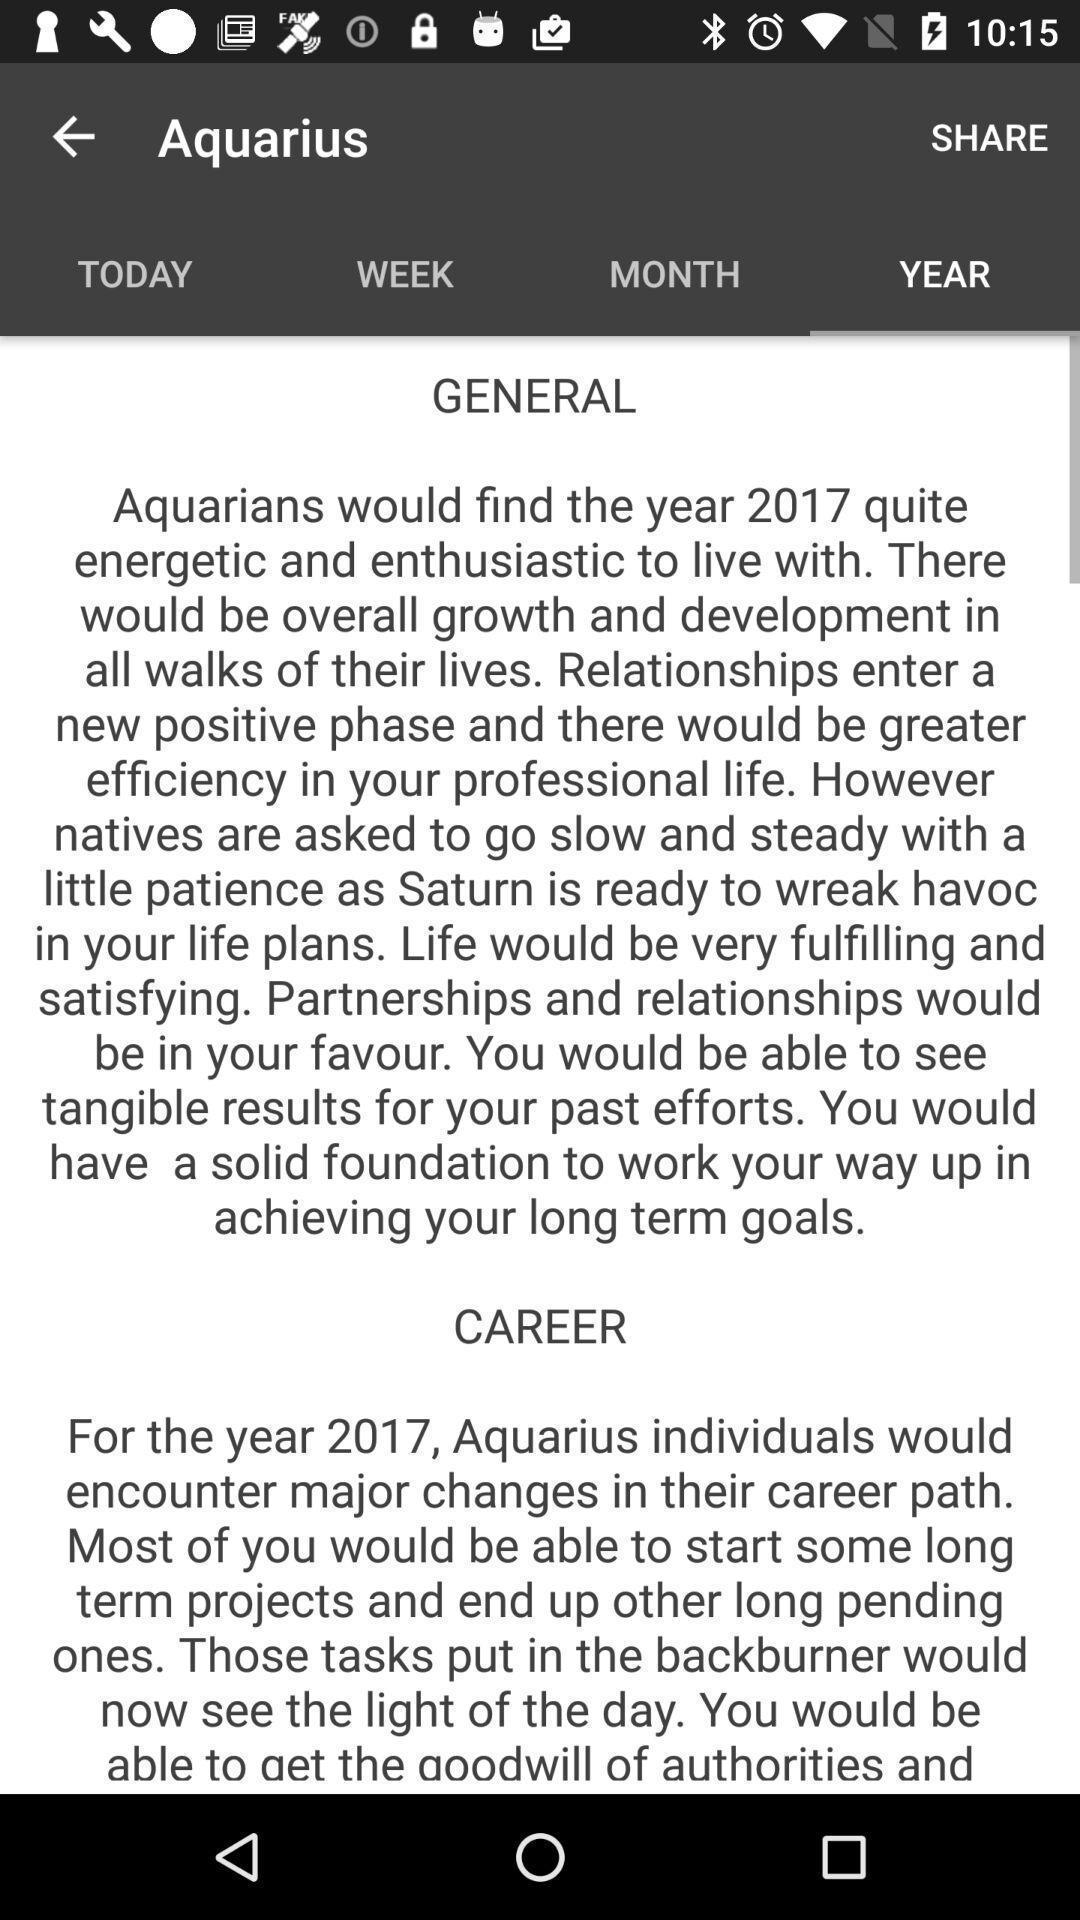Tell me what you see in this picture. Page showing information of a sign. 